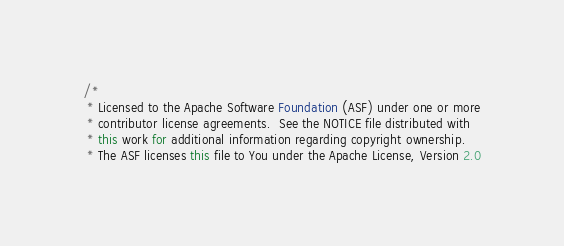<code> <loc_0><loc_0><loc_500><loc_500><_Java_>/*
 * Licensed to the Apache Software Foundation (ASF) under one or more
 * contributor license agreements.  See the NOTICE file distributed with
 * this work for additional information regarding copyright ownership.
 * The ASF licenses this file to You under the Apache License, Version 2.0</code> 